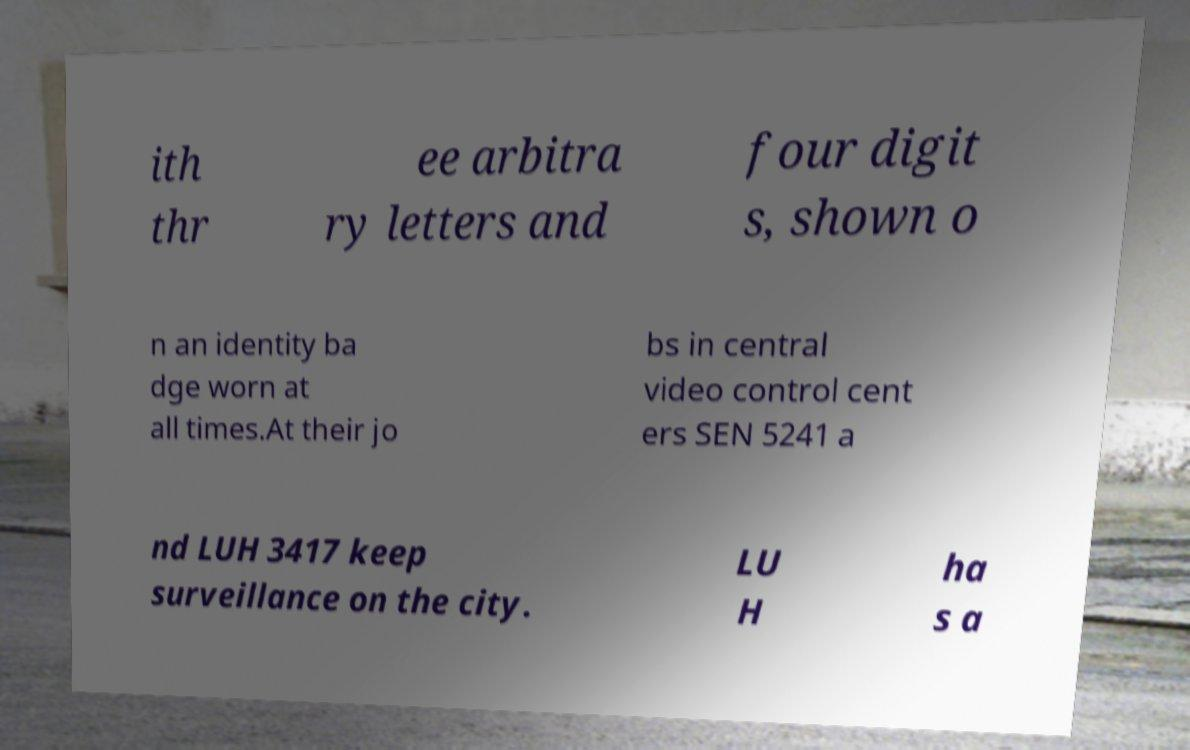I need the written content from this picture converted into text. Can you do that? ith thr ee arbitra ry letters and four digit s, shown o n an identity ba dge worn at all times.At their jo bs in central video control cent ers SEN 5241 a nd LUH 3417 keep surveillance on the city. LU H ha s a 